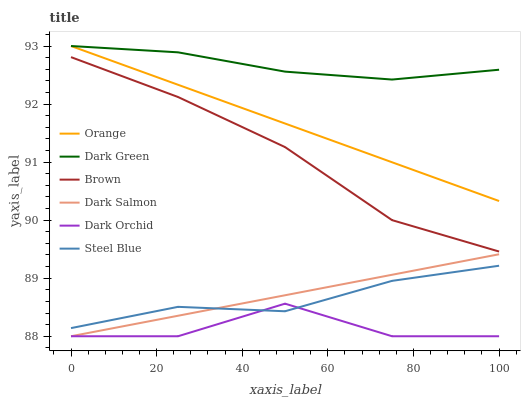Does Dark Orchid have the minimum area under the curve?
Answer yes or no. Yes. Does Dark Green have the maximum area under the curve?
Answer yes or no. Yes. Does Steel Blue have the minimum area under the curve?
Answer yes or no. No. Does Steel Blue have the maximum area under the curve?
Answer yes or no. No. Is Dark Salmon the smoothest?
Answer yes or no. Yes. Is Dark Orchid the roughest?
Answer yes or no. Yes. Is Steel Blue the smoothest?
Answer yes or no. No. Is Steel Blue the roughest?
Answer yes or no. No. Does Dark Orchid have the lowest value?
Answer yes or no. Yes. Does Steel Blue have the lowest value?
Answer yes or no. No. Does Dark Green have the highest value?
Answer yes or no. Yes. Does Steel Blue have the highest value?
Answer yes or no. No. Is Dark Salmon less than Brown?
Answer yes or no. Yes. Is Dark Green greater than Dark Orchid?
Answer yes or no. Yes. Does Steel Blue intersect Dark Salmon?
Answer yes or no. Yes. Is Steel Blue less than Dark Salmon?
Answer yes or no. No. Is Steel Blue greater than Dark Salmon?
Answer yes or no. No. Does Dark Salmon intersect Brown?
Answer yes or no. No. 